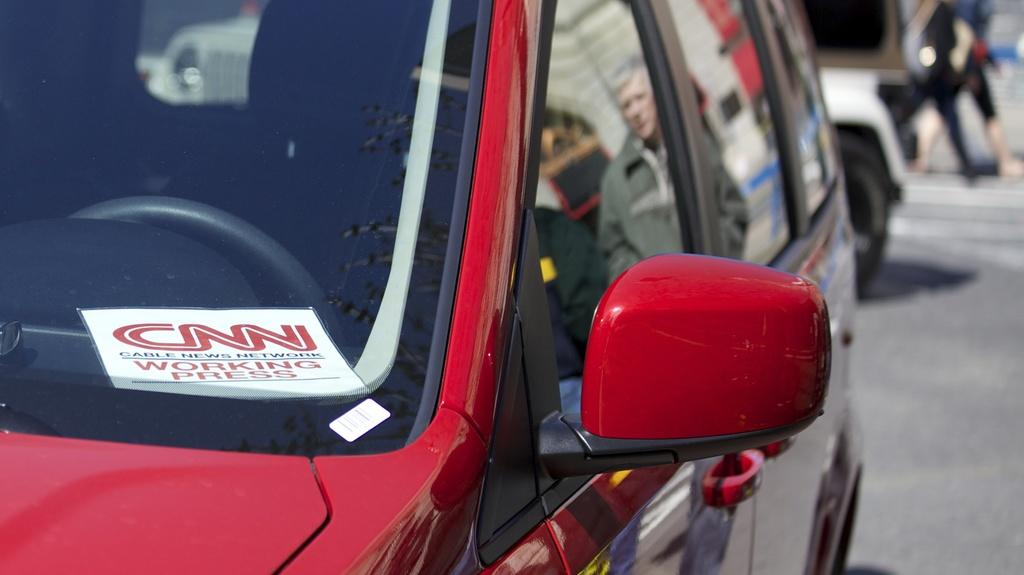What type of vehicles can be seen on the road in the image? There are motor vehicles on the road in the image. Can you see any slopes or donkeys in the image? There are no slopes or donkeys present in the image; it only features motor vehicles on the road. 